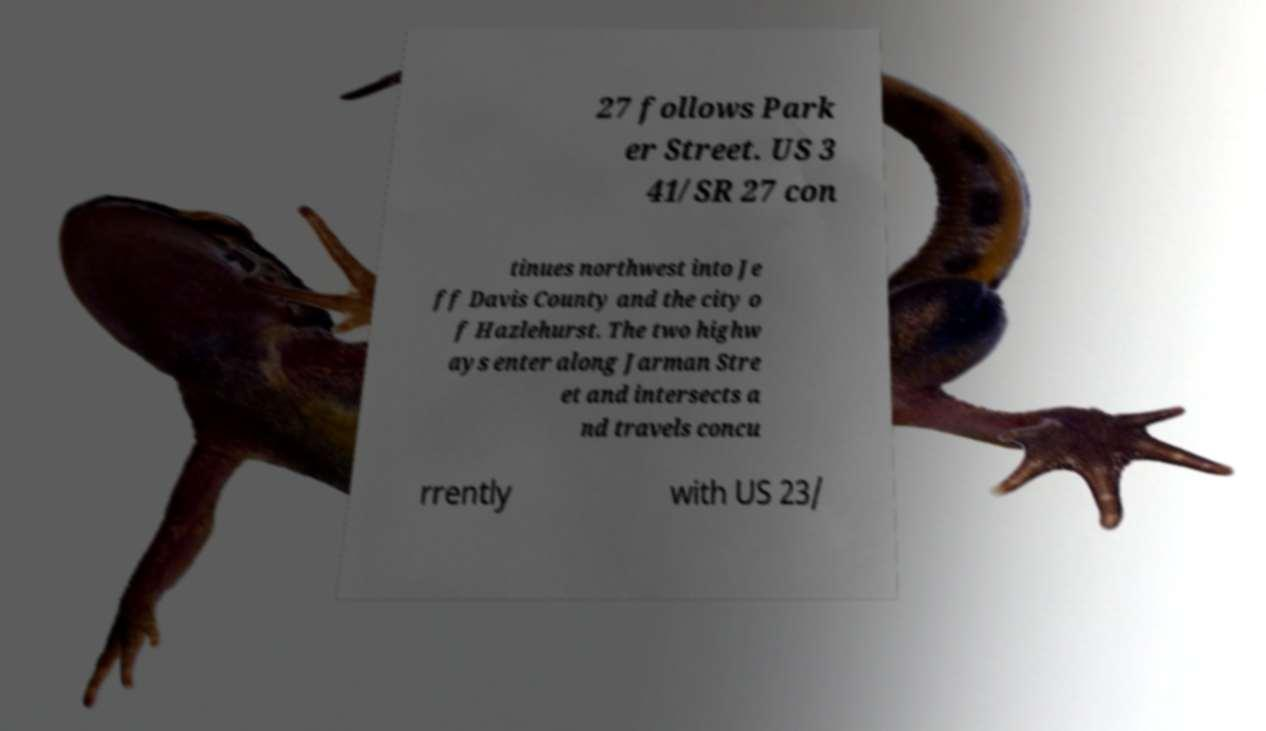I need the written content from this picture converted into text. Can you do that? 27 follows Park er Street. US 3 41/SR 27 con tinues northwest into Je ff Davis County and the city o f Hazlehurst. The two highw ays enter along Jarman Stre et and intersects a nd travels concu rrently with US 23/ 